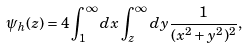<formula> <loc_0><loc_0><loc_500><loc_500>\psi _ { h } ( z ) = 4 \int _ { 1 } ^ { \infty } d x \int _ { z } ^ { \infty } d y \frac { 1 } { ( x ^ { 2 } + y ^ { 2 } ) ^ { 2 } } ,</formula> 